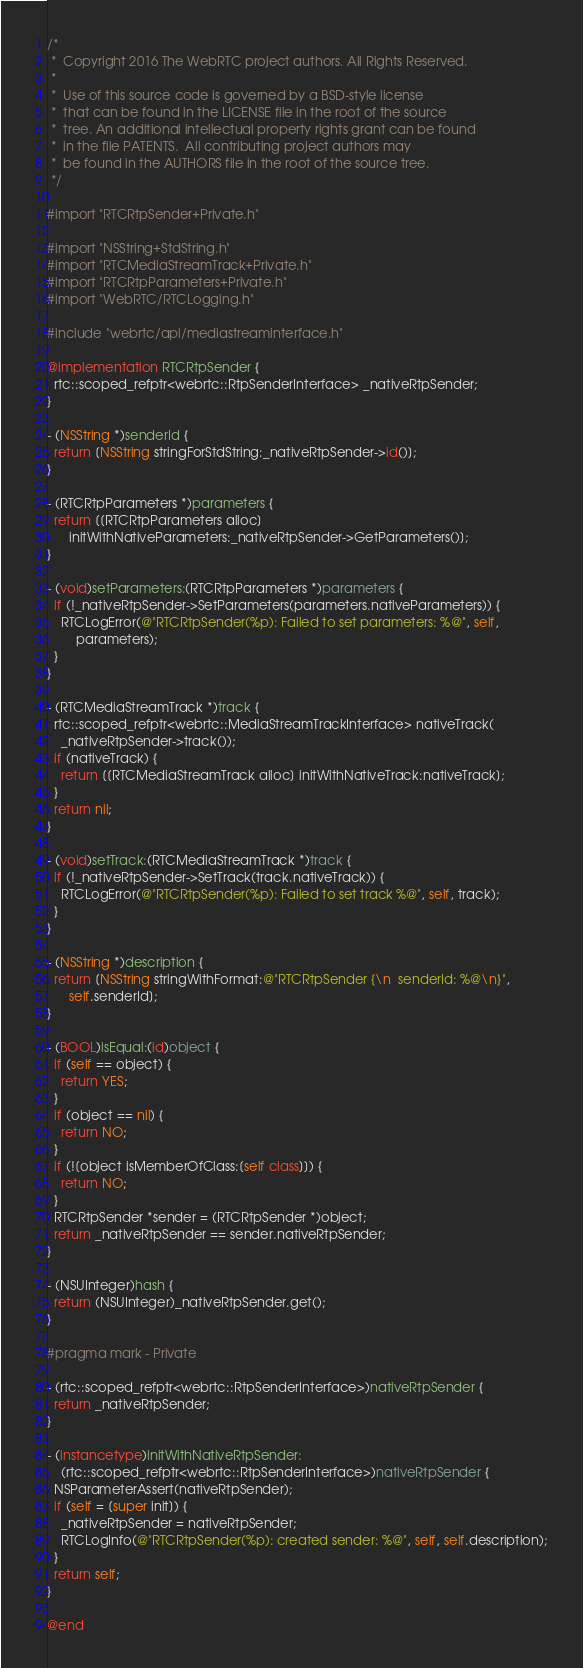Convert code to text. <code><loc_0><loc_0><loc_500><loc_500><_ObjectiveC_>/*
 *  Copyright 2016 The WebRTC project authors. All Rights Reserved.
 *
 *  Use of this source code is governed by a BSD-style license
 *  that can be found in the LICENSE file in the root of the source
 *  tree. An additional intellectual property rights grant can be found
 *  in the file PATENTS.  All contributing project authors may
 *  be found in the AUTHORS file in the root of the source tree.
 */

#import "RTCRtpSender+Private.h"

#import "NSString+StdString.h"
#import "RTCMediaStreamTrack+Private.h"
#import "RTCRtpParameters+Private.h"
#import "WebRTC/RTCLogging.h"

#include "webrtc/api/mediastreaminterface.h"

@implementation RTCRtpSender {
  rtc::scoped_refptr<webrtc::RtpSenderInterface> _nativeRtpSender;
}

- (NSString *)senderId {
  return [NSString stringForStdString:_nativeRtpSender->id()];
}

- (RTCRtpParameters *)parameters {
  return [[RTCRtpParameters alloc]
      initWithNativeParameters:_nativeRtpSender->GetParameters()];
}

- (void)setParameters:(RTCRtpParameters *)parameters {
  if (!_nativeRtpSender->SetParameters(parameters.nativeParameters)) {
    RTCLogError(@"RTCRtpSender(%p): Failed to set parameters: %@", self,
        parameters);
  }
}

- (RTCMediaStreamTrack *)track {
  rtc::scoped_refptr<webrtc::MediaStreamTrackInterface> nativeTrack(
    _nativeRtpSender->track());
  if (nativeTrack) {
    return [[RTCMediaStreamTrack alloc] initWithNativeTrack:nativeTrack];
  }
  return nil;
}

- (void)setTrack:(RTCMediaStreamTrack *)track {
  if (!_nativeRtpSender->SetTrack(track.nativeTrack)) {
    RTCLogError(@"RTCRtpSender(%p): Failed to set track %@", self, track);
  }
}

- (NSString *)description {
  return [NSString stringWithFormat:@"RTCRtpSender {\n  senderId: %@\n}",
      self.senderId];
}

- (BOOL)isEqual:(id)object {
  if (self == object) {
    return YES;
  }
  if (object == nil) {
    return NO;
  }
  if (![object isMemberOfClass:[self class]]) {
    return NO;
  }
  RTCRtpSender *sender = (RTCRtpSender *)object;
  return _nativeRtpSender == sender.nativeRtpSender;
}

- (NSUInteger)hash {
  return (NSUInteger)_nativeRtpSender.get();
}

#pragma mark - Private

- (rtc::scoped_refptr<webrtc::RtpSenderInterface>)nativeRtpSender {
  return _nativeRtpSender;
}

- (instancetype)initWithNativeRtpSender:
    (rtc::scoped_refptr<webrtc::RtpSenderInterface>)nativeRtpSender {
  NSParameterAssert(nativeRtpSender);
  if (self = [super init]) {
    _nativeRtpSender = nativeRtpSender;
    RTCLogInfo(@"RTCRtpSender(%p): created sender: %@", self, self.description);
  }
  return self;
}

@end
</code> 